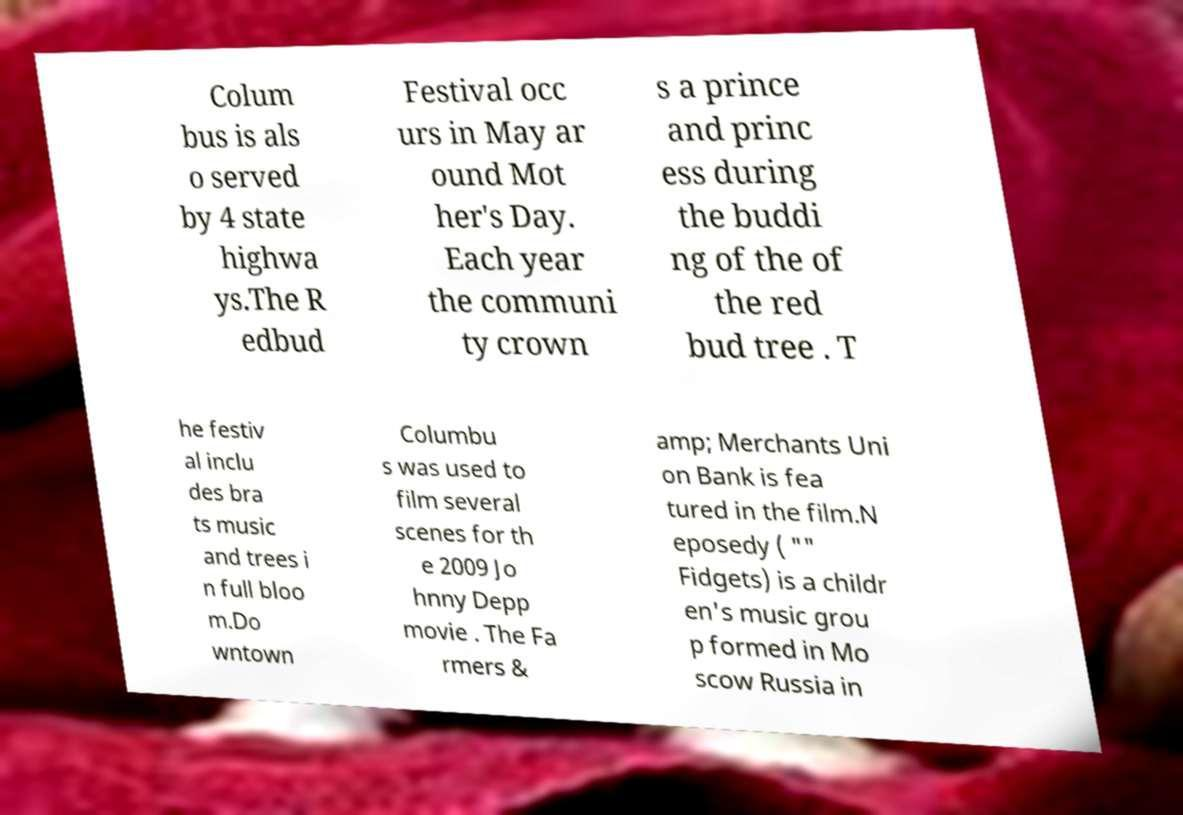For documentation purposes, I need the text within this image transcribed. Could you provide that? Colum bus is als o served by 4 state highwa ys.The R edbud Festival occ urs in May ar ound Mot her's Day. Each year the communi ty crown s a prince and princ ess during the buddi ng of the of the red bud tree . T he festiv al inclu des bra ts music and trees i n full bloo m.Do wntown Columbu s was used to film several scenes for th e 2009 Jo hnny Depp movie . The Fa rmers & amp; Merchants Uni on Bank is fea tured in the film.N eposedy ( "" Fidgets) is a childr en's music grou p formed in Mo scow Russia in 